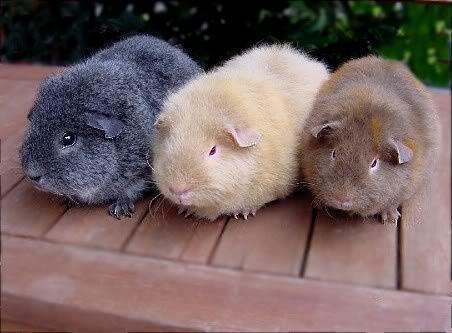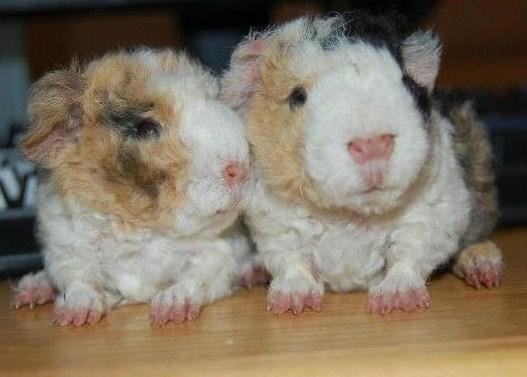The first image is the image on the left, the second image is the image on the right. Given the left and right images, does the statement "The left image contains a row of three guinea pigs, and the right image contains two guinea pigs with wavy fur." hold true? Answer yes or no. Yes. The first image is the image on the left, the second image is the image on the right. Examine the images to the left and right. Is the description "The right image contains exactly two rodents." accurate? Answer yes or no. Yes. 